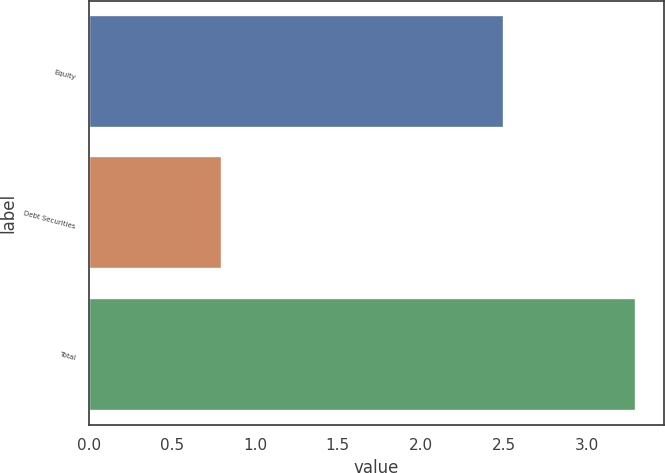Convert chart. <chart><loc_0><loc_0><loc_500><loc_500><bar_chart><fcel>Equity<fcel>Debt Securities<fcel>Total<nl><fcel>2.5<fcel>0.8<fcel>3.3<nl></chart> 